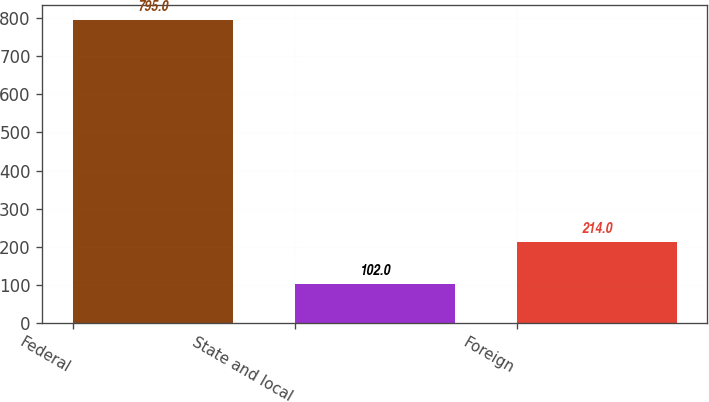Convert chart to OTSL. <chart><loc_0><loc_0><loc_500><loc_500><bar_chart><fcel>Federal<fcel>State and local<fcel>Foreign<nl><fcel>795<fcel>102<fcel>214<nl></chart> 